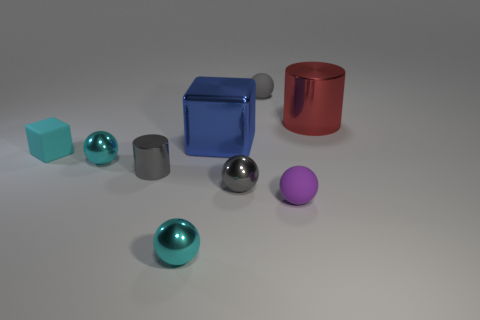Subtract all small gray spheres. How many spheres are left? 3 Add 1 cyan rubber objects. How many objects exist? 10 Subtract 1 cubes. How many cubes are left? 1 Subtract all brown blocks. How many gray balls are left? 2 Subtract all cylinders. How many objects are left? 7 Subtract all purple balls. How many balls are left? 4 Subtract 1 red cylinders. How many objects are left? 8 Subtract all blue cylinders. Subtract all purple balls. How many cylinders are left? 2 Subtract all small gray rubber spheres. Subtract all small cyan matte objects. How many objects are left? 7 Add 6 red shiny things. How many red shiny things are left? 7 